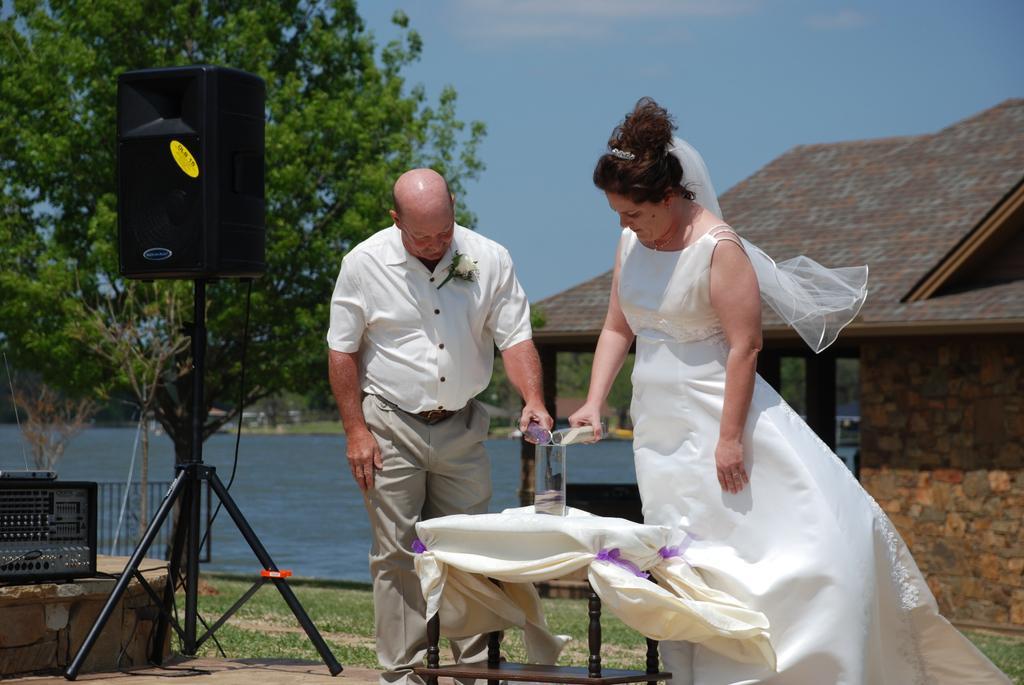How would you summarize this image in a sentence or two? In this image I can see a woman and a man is standing. In the background I can see a speaker, a tree and a house. I can see both of them are holding glass. 